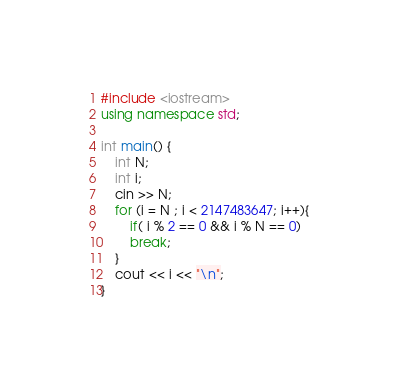<code> <loc_0><loc_0><loc_500><loc_500><_C++_>#include <iostream>
using namespace std;

int main() {
    int N;
    int i;
    cin >> N;
    for (i = N ; i < 2147483647; i++){
        if( i % 2 == 0 && i % N == 0)
        break;
    }
    cout << i << "\n";
}</code> 